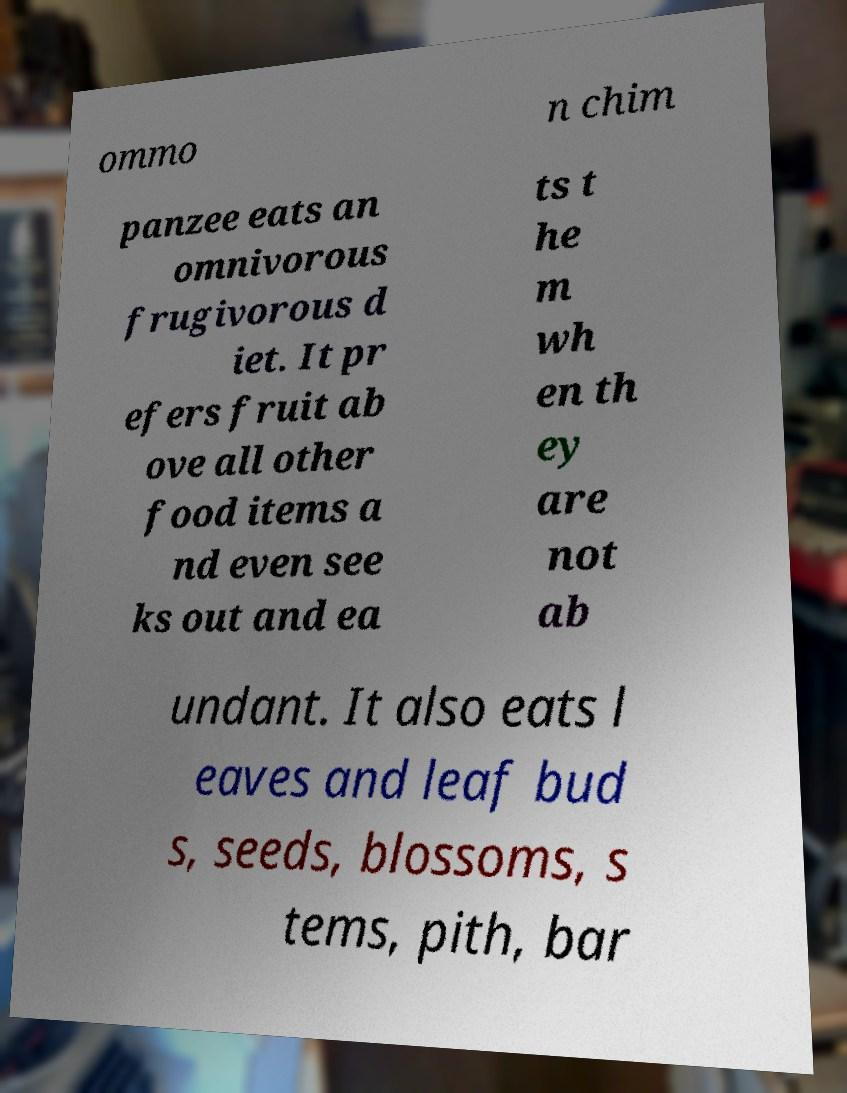For documentation purposes, I need the text within this image transcribed. Could you provide that? ommo n chim panzee eats an omnivorous frugivorous d iet. It pr efers fruit ab ove all other food items a nd even see ks out and ea ts t he m wh en th ey are not ab undant. It also eats l eaves and leaf bud s, seeds, blossoms, s tems, pith, bar 